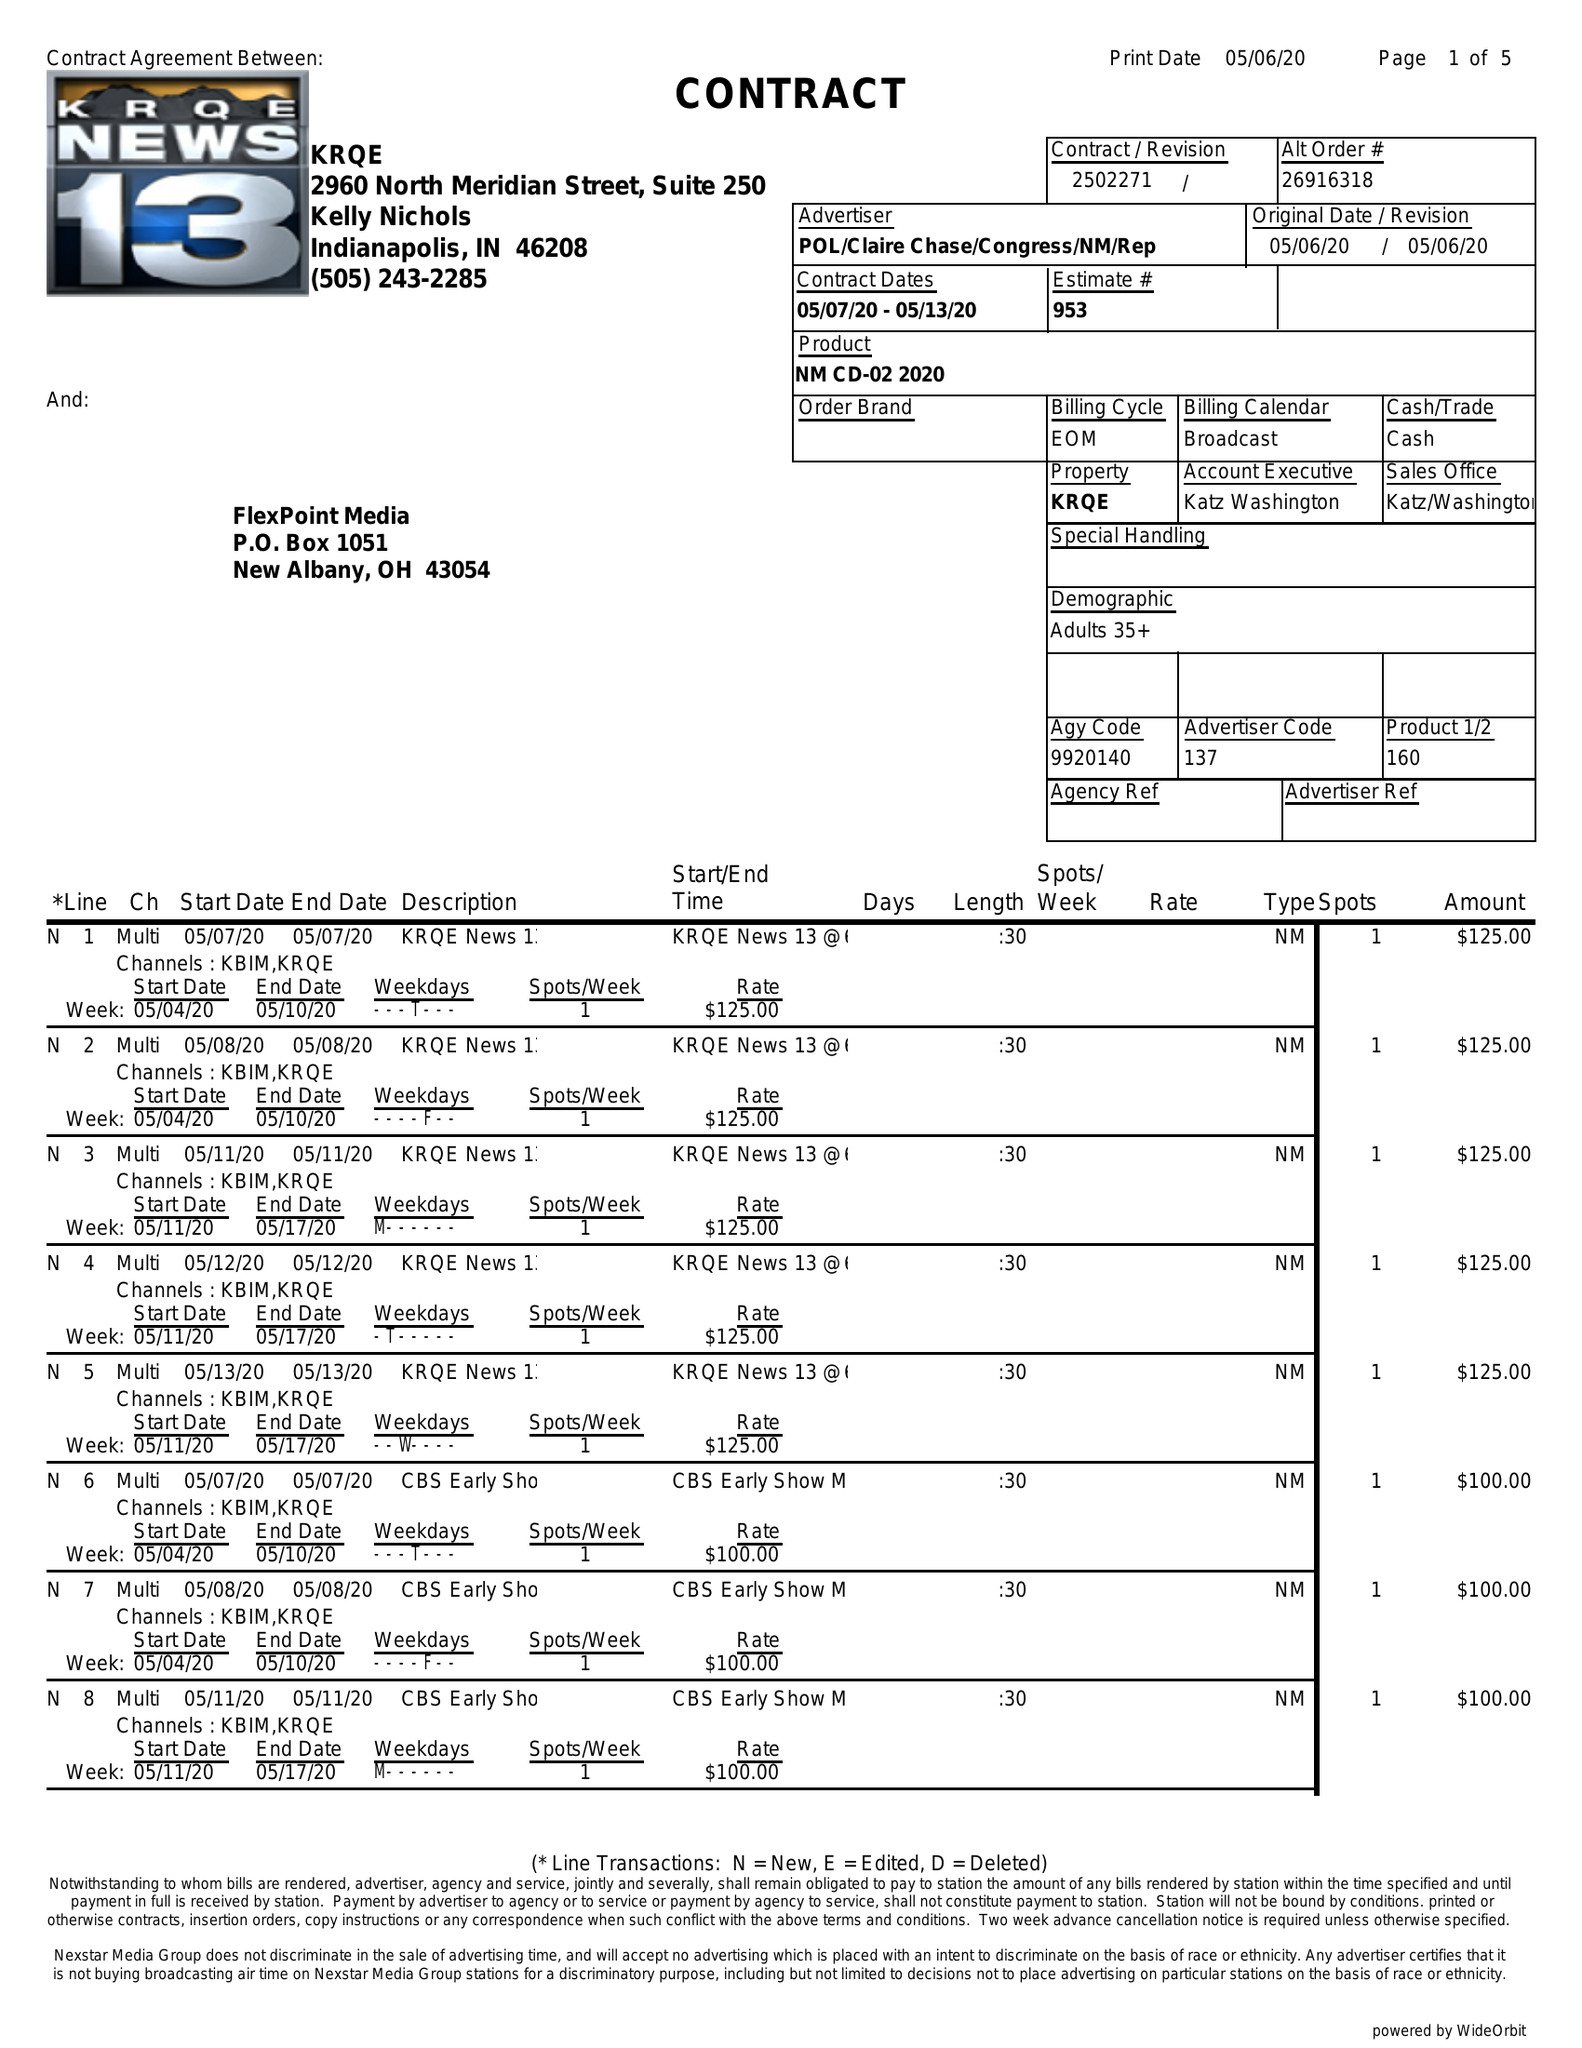What is the value for the flight_to?
Answer the question using a single word or phrase. 05/13/20 